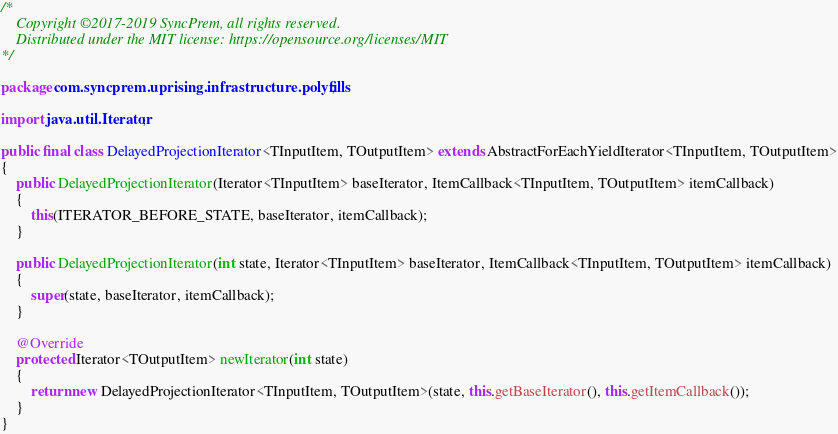Convert code to text. <code><loc_0><loc_0><loc_500><loc_500><_Java_>/*
	Copyright ©2017-2019 SyncPrem, all rights reserved.
	Distributed under the MIT license: https://opensource.org/licenses/MIT
*/

package com.syncprem.uprising.infrastructure.polyfills;

import java.util.Iterator;

public final class DelayedProjectionIterator<TInputItem, TOutputItem> extends AbstractForEachYieldIterator<TInputItem, TOutputItem>
{
	public DelayedProjectionIterator(Iterator<TInputItem> baseIterator, ItemCallback<TInputItem, TOutputItem> itemCallback)
	{
		this(ITERATOR_BEFORE_STATE, baseIterator, itemCallback);
	}

	public DelayedProjectionIterator(int state, Iterator<TInputItem> baseIterator, ItemCallback<TInputItem, TOutputItem> itemCallback)
	{
		super(state, baseIterator, itemCallback);
	}

	@Override
	protected Iterator<TOutputItem> newIterator(int state)
	{
		return new DelayedProjectionIterator<TInputItem, TOutputItem>(state, this.getBaseIterator(), this.getItemCallback());
	}
}
</code> 